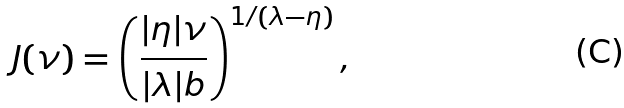<formula> <loc_0><loc_0><loc_500><loc_500>J ( \nu ) = \left ( \frac { | \eta | \nu } { | \lambda | b } \right ) ^ { 1 / ( \lambda - \eta ) } ,</formula> 